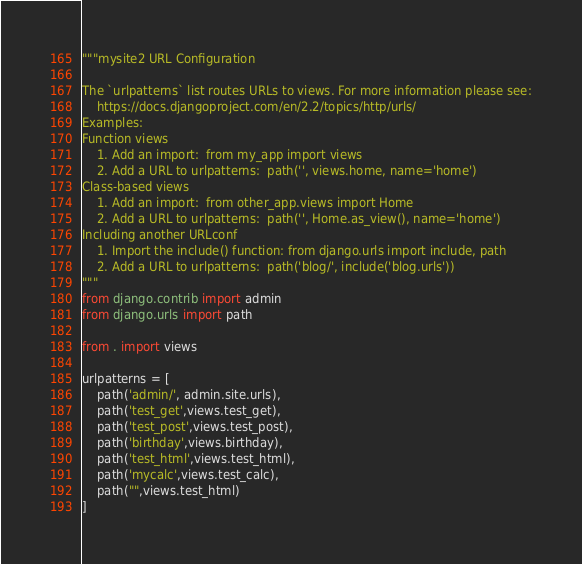Convert code to text. <code><loc_0><loc_0><loc_500><loc_500><_Python_>"""mysite2 URL Configuration

The `urlpatterns` list routes URLs to views. For more information please see:
    https://docs.djangoproject.com/en/2.2/topics/http/urls/
Examples:
Function views
    1. Add an import:  from my_app import views
    2. Add a URL to urlpatterns:  path('', views.home, name='home')
Class-based views
    1. Add an import:  from other_app.views import Home
    2. Add a URL to urlpatterns:  path('', Home.as_view(), name='home')
Including another URLconf
    1. Import the include() function: from django.urls import include, path
    2. Add a URL to urlpatterns:  path('blog/', include('blog.urls'))
"""
from django.contrib import admin
from django.urls import path

from . import views

urlpatterns = [
    path('admin/', admin.site.urls),
    path('test_get',views.test_get),
    path('test_post',views.test_post),
    path('birthday',views.birthday),
    path('test_html',views.test_html),
    path('mycalc',views.test_calc),
    path("",views.test_html)
]
</code> 